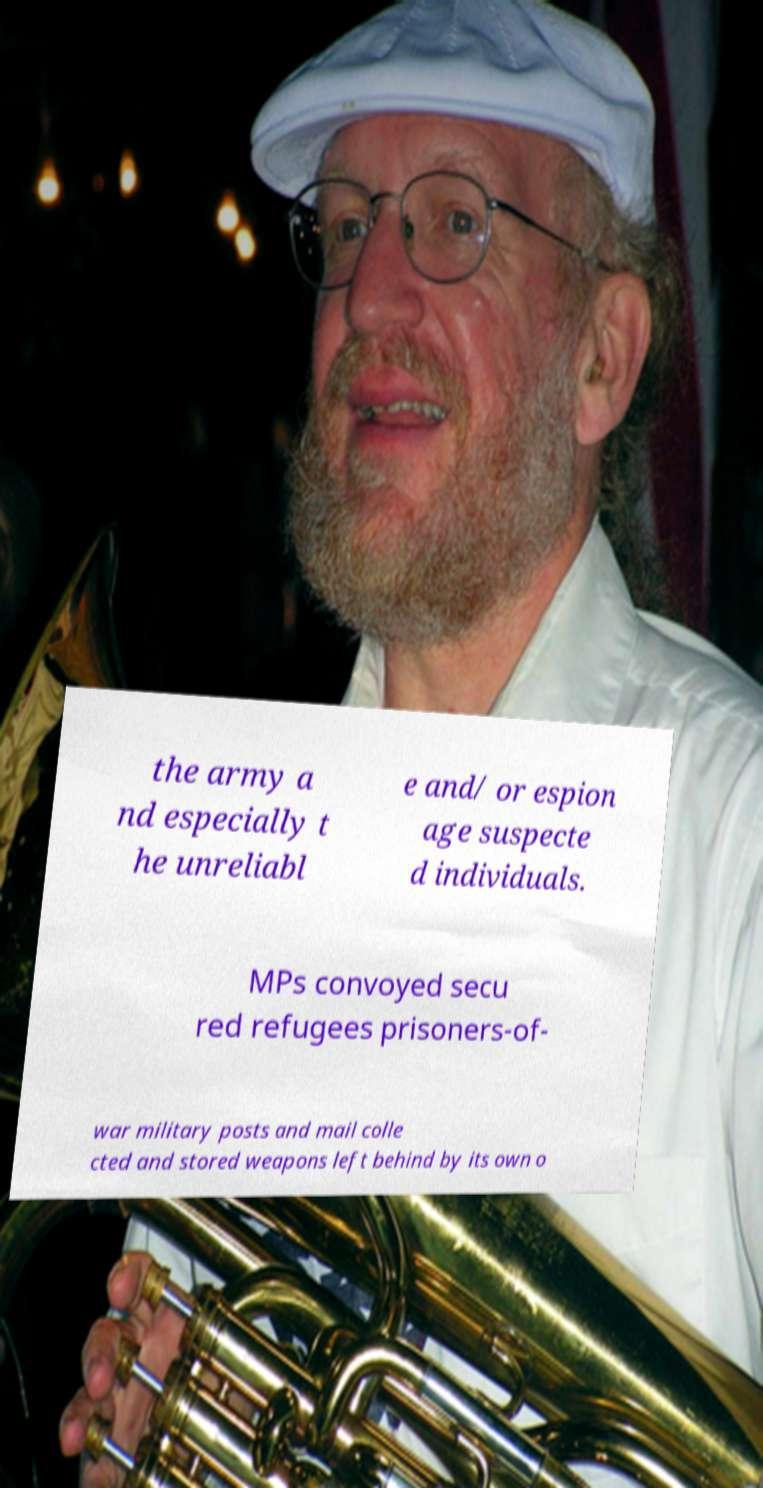Please identify and transcribe the text found in this image. the army a nd especially t he unreliabl e and/ or espion age suspecte d individuals. MPs convoyed secu red refugees prisoners-of- war military posts and mail colle cted and stored weapons left behind by its own o 